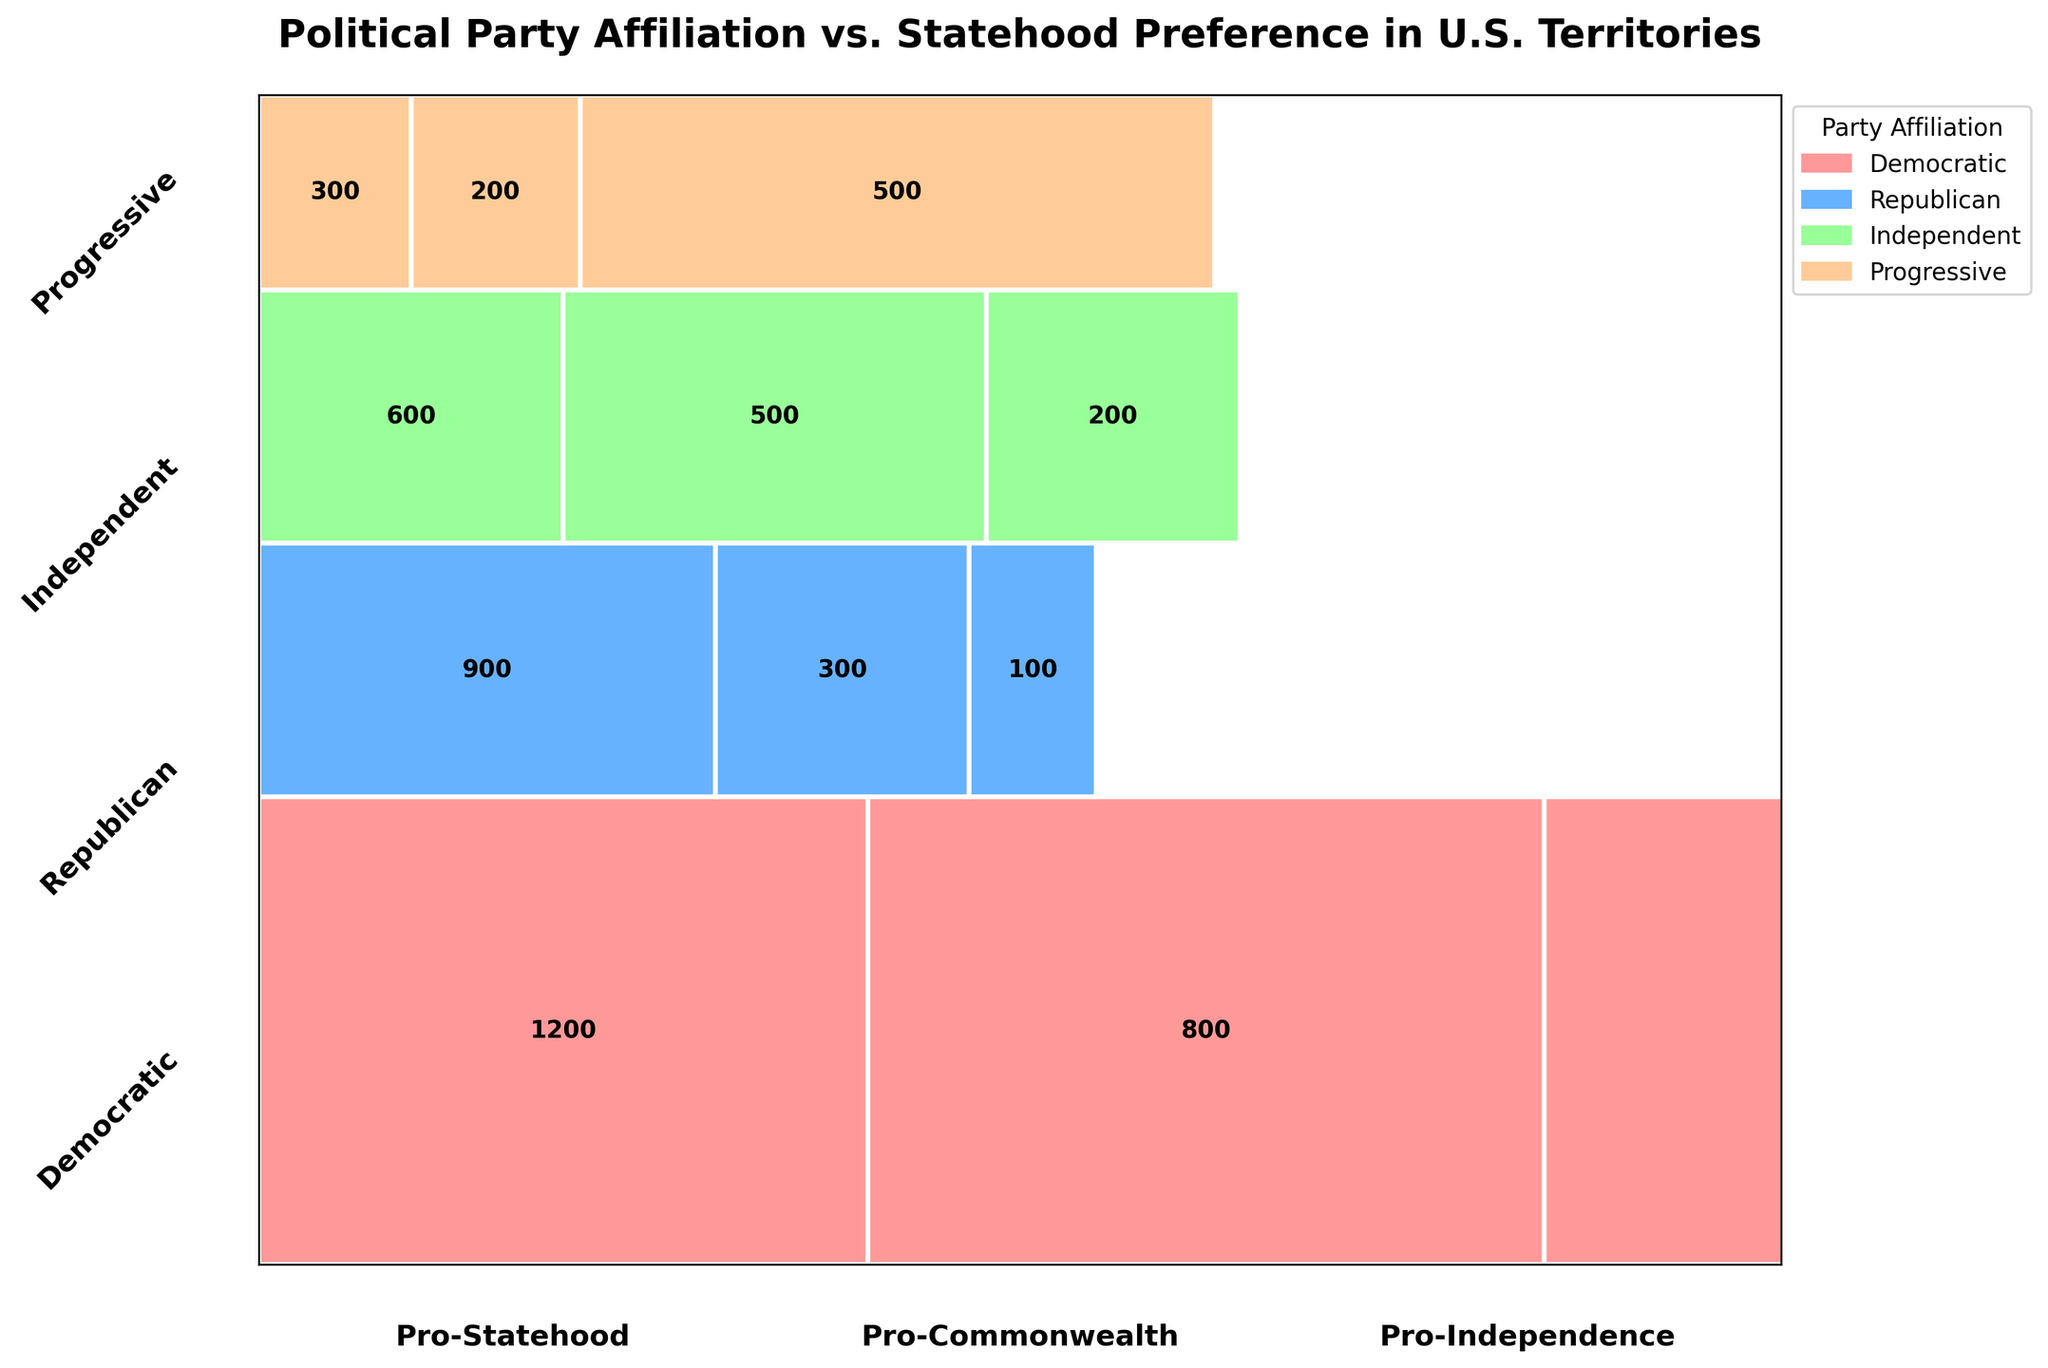What is the title of the mosaic plot? The title is located at the top of the plot and prominently displayed. It helps introduce the purpose of the visualization.
Answer: Political Party Affiliation vs. Statehood Preference in U.S. Territories Which party has the highest number of members favoring statehood? By looking at the widths of the rectangles in the "Pro-Statehood" column, the Democratic Party has the widest one. The annotated number confirms it.
Answer: Democratic How many Republican members prefer commonwealth status? The number is directly annotated on the plot within the "Republican" row and "Pro-Commonwealth" column.
Answer: 300 Compare the number of Independents who prefer independence to the number of Progressives who prefer statehood. The numbers are annotated in the respective rectangles. Independents preferring independence are 200, and Progressives preferring statehood are 300.
Answer: More Progressives prefer statehood What is the total number of individuals preferring pro-independence? Summing the annotations in the "Pro-Independence" column: 400 (Democratic) + 100 (Republican) + 200 (Independent) + 500 (Progressive).
Answer: 1200 Which statehood preference has the least support among Republicans? Compare the counts of the Republican row. Independence has the lowest number with 100.
Answer: Pro-Independence What percentage of Democratic members support commonwealth status? The Democratic party has 800 out of the total 2400 Democrats. The percentage is (800/2400) * 100%.
Answer: 33.3% How does the number of Independents preferring statehood compare to the number of Democrats preferring commonwealth? The numbers are annotated. Independents (600) vs. Democrats (800).
Answer: Democrats preferring commonwealth are more Among the Progressive members, which statehood preference has the highest support? Reviewing the annotations in the Progressive row, "Pro-Independence" has the highest number with 500.
Answer: Pro-Independence What is the total count of Independent members across all statehood preferences? Sum the annotations in the Independent row: 600 (Statehood) + 500 (Commonwealth) + 200 (Independence).
Answer: 1300 